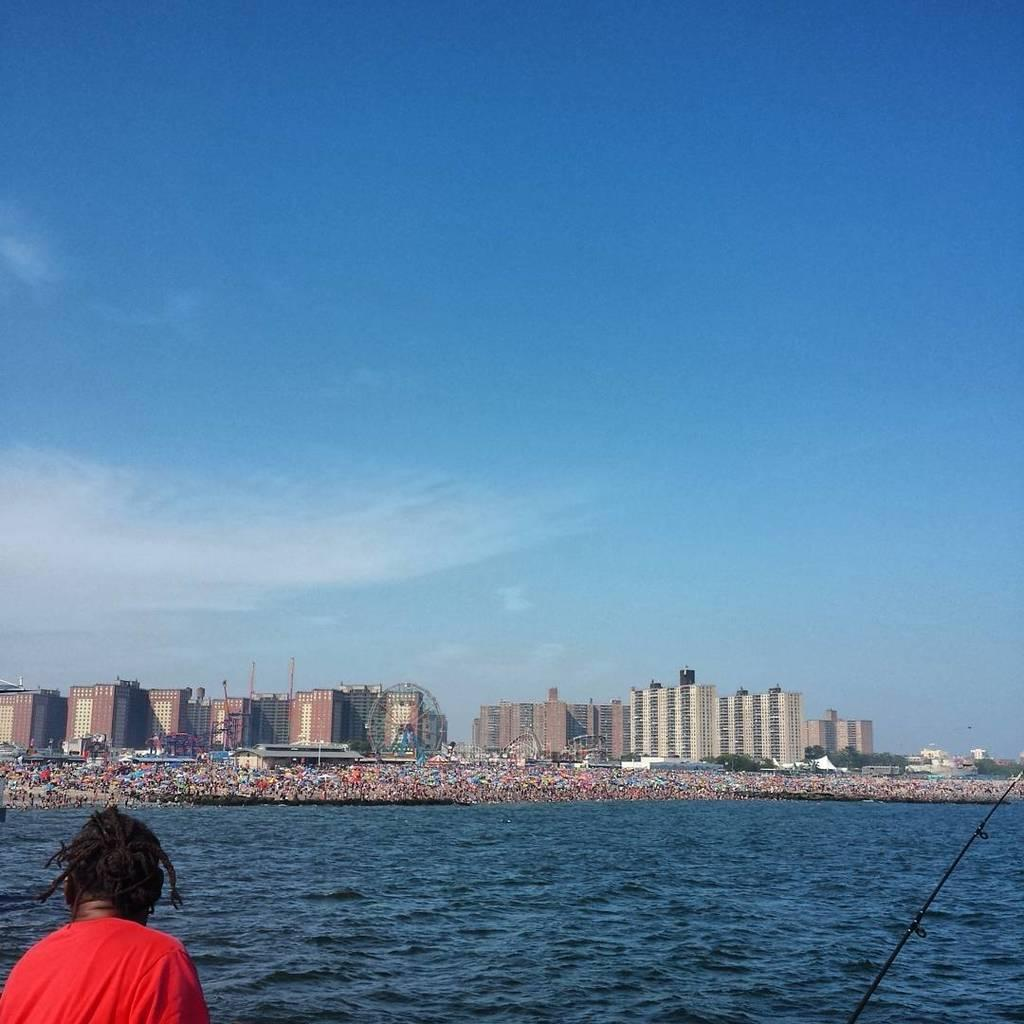What is present in the image? There is a person in the image. What is the person wearing? The person is wearing a red shirt. What can be seen in the background of the image? There is water and white-colored buildings visible in the background of the image. How would you describe the sky in the image? The sky is blue and white in color. How far away is the toy from the person in the image? There is no toy present in the image, so it is not possible to determine the distance between the person and a toy. 